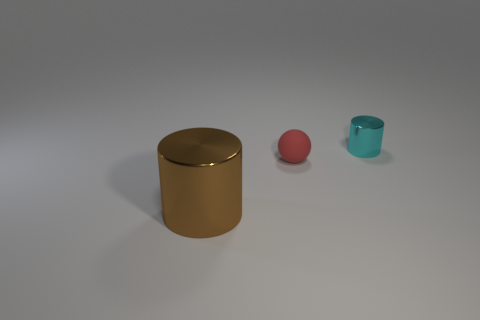What materials do the objects in the image appear to be made of? The large cylindrical object appears to have a metallic surface, possibly resembling bronze or copper, reflecting light on its curved surface. The small sphere looks like it could be made of a matte material, perhaps plastic or rubber, given its non-reflective surface. The tiny cylinder has a slightly translucent appearance and could be made of glass or a transparent plastic. 